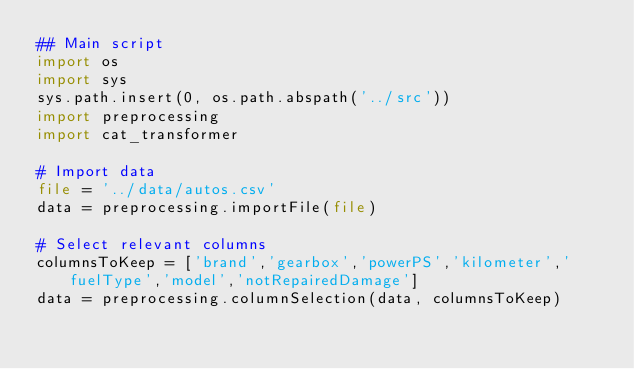Convert code to text. <code><loc_0><loc_0><loc_500><loc_500><_Python_>## Main script
import os
import sys
sys.path.insert(0, os.path.abspath('../src'))
import preprocessing
import cat_transformer

# Import data
file = '../data/autos.csv'
data = preprocessing.importFile(file)

# Select relevant columns
columnsToKeep = ['brand','gearbox','powerPS','kilometer','fuelType','model','notRepairedDamage']
data = preprocessing.columnSelection(data, columnsToKeep)</code> 